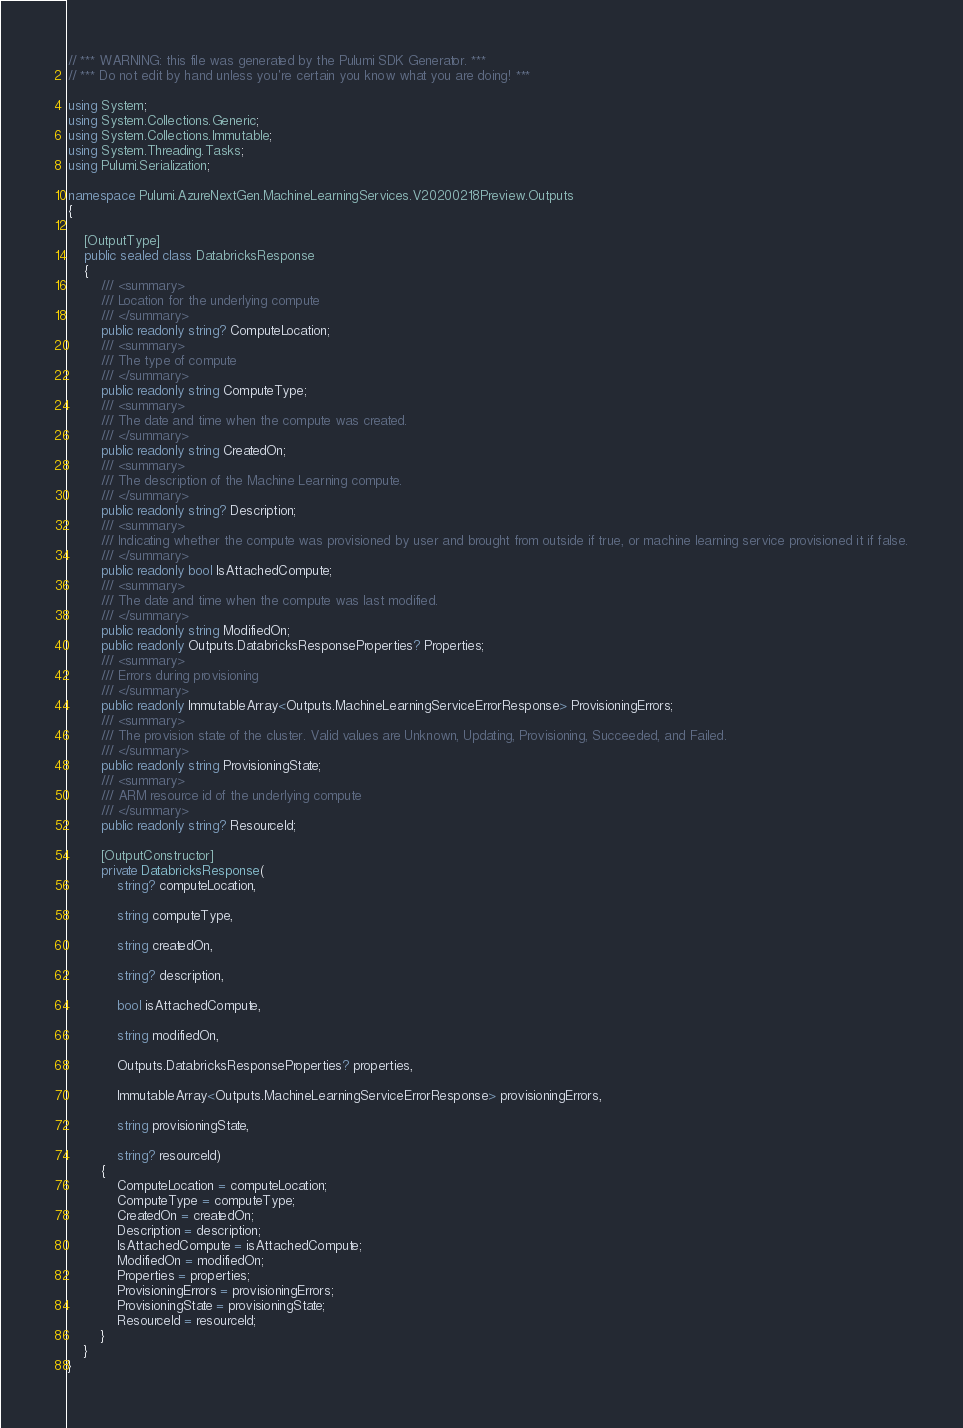<code> <loc_0><loc_0><loc_500><loc_500><_C#_>// *** WARNING: this file was generated by the Pulumi SDK Generator. ***
// *** Do not edit by hand unless you're certain you know what you are doing! ***

using System;
using System.Collections.Generic;
using System.Collections.Immutable;
using System.Threading.Tasks;
using Pulumi.Serialization;

namespace Pulumi.AzureNextGen.MachineLearningServices.V20200218Preview.Outputs
{

    [OutputType]
    public sealed class DatabricksResponse
    {
        /// <summary>
        /// Location for the underlying compute
        /// </summary>
        public readonly string? ComputeLocation;
        /// <summary>
        /// The type of compute
        /// </summary>
        public readonly string ComputeType;
        /// <summary>
        /// The date and time when the compute was created.
        /// </summary>
        public readonly string CreatedOn;
        /// <summary>
        /// The description of the Machine Learning compute.
        /// </summary>
        public readonly string? Description;
        /// <summary>
        /// Indicating whether the compute was provisioned by user and brought from outside if true, or machine learning service provisioned it if false.
        /// </summary>
        public readonly bool IsAttachedCompute;
        /// <summary>
        /// The date and time when the compute was last modified.
        /// </summary>
        public readonly string ModifiedOn;
        public readonly Outputs.DatabricksResponseProperties? Properties;
        /// <summary>
        /// Errors during provisioning
        /// </summary>
        public readonly ImmutableArray<Outputs.MachineLearningServiceErrorResponse> ProvisioningErrors;
        /// <summary>
        /// The provision state of the cluster. Valid values are Unknown, Updating, Provisioning, Succeeded, and Failed.
        /// </summary>
        public readonly string ProvisioningState;
        /// <summary>
        /// ARM resource id of the underlying compute
        /// </summary>
        public readonly string? ResourceId;

        [OutputConstructor]
        private DatabricksResponse(
            string? computeLocation,

            string computeType,

            string createdOn,

            string? description,

            bool isAttachedCompute,

            string modifiedOn,

            Outputs.DatabricksResponseProperties? properties,

            ImmutableArray<Outputs.MachineLearningServiceErrorResponse> provisioningErrors,

            string provisioningState,

            string? resourceId)
        {
            ComputeLocation = computeLocation;
            ComputeType = computeType;
            CreatedOn = createdOn;
            Description = description;
            IsAttachedCompute = isAttachedCompute;
            ModifiedOn = modifiedOn;
            Properties = properties;
            ProvisioningErrors = provisioningErrors;
            ProvisioningState = provisioningState;
            ResourceId = resourceId;
        }
    }
}
</code> 